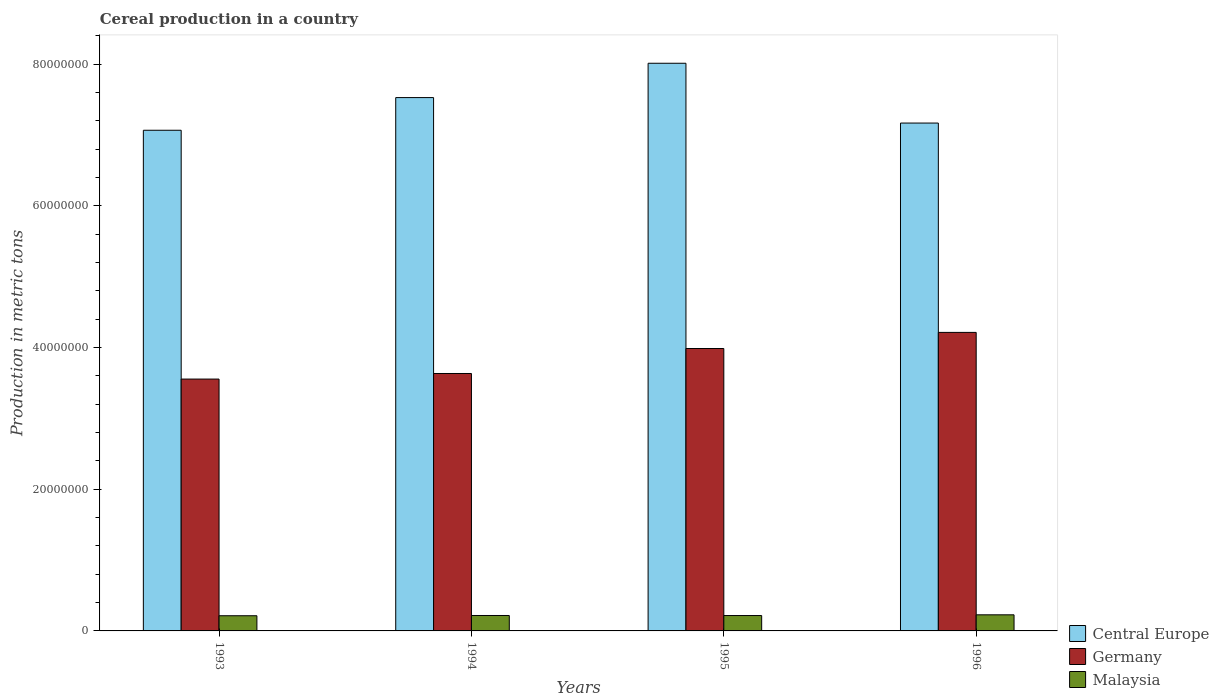How many groups of bars are there?
Offer a very short reply. 4. Are the number of bars on each tick of the X-axis equal?
Keep it short and to the point. Yes. How many bars are there on the 4th tick from the left?
Offer a very short reply. 3. How many bars are there on the 2nd tick from the right?
Your response must be concise. 3. In how many cases, is the number of bars for a given year not equal to the number of legend labels?
Provide a succinct answer. 0. What is the total cereal production in Central Europe in 1995?
Your answer should be very brief. 8.01e+07. Across all years, what is the maximum total cereal production in Germany?
Ensure brevity in your answer.  4.21e+07. Across all years, what is the minimum total cereal production in Central Europe?
Provide a short and direct response. 7.07e+07. In which year was the total cereal production in Germany minimum?
Your response must be concise. 1993. What is the total total cereal production in Central Europe in the graph?
Offer a very short reply. 2.98e+08. What is the difference between the total cereal production in Germany in 1995 and that in 1996?
Provide a short and direct response. -2.27e+06. What is the difference between the total cereal production in Central Europe in 1996 and the total cereal production in Malaysia in 1995?
Provide a succinct answer. 6.95e+07. What is the average total cereal production in Central Europe per year?
Provide a succinct answer. 7.44e+07. In the year 1993, what is the difference between the total cereal production in Malaysia and total cereal production in Central Europe?
Make the answer very short. -6.85e+07. What is the ratio of the total cereal production in Germany in 1994 to that in 1995?
Keep it short and to the point. 0.91. Is the total cereal production in Central Europe in 1993 less than that in 1996?
Offer a terse response. Yes. Is the difference between the total cereal production in Malaysia in 1993 and 1996 greater than the difference between the total cereal production in Central Europe in 1993 and 1996?
Make the answer very short. Yes. What is the difference between the highest and the second highest total cereal production in Central Europe?
Provide a short and direct response. 4.85e+06. What is the difference between the highest and the lowest total cereal production in Malaysia?
Ensure brevity in your answer.  1.31e+05. What does the 3rd bar from the right in 1993 represents?
Provide a short and direct response. Central Europe. How many bars are there?
Your answer should be very brief. 12. Are all the bars in the graph horizontal?
Make the answer very short. No. How many years are there in the graph?
Ensure brevity in your answer.  4. What is the difference between two consecutive major ticks on the Y-axis?
Provide a succinct answer. 2.00e+07. Are the values on the major ticks of Y-axis written in scientific E-notation?
Make the answer very short. No. Does the graph contain any zero values?
Make the answer very short. No. Does the graph contain grids?
Provide a short and direct response. No. How many legend labels are there?
Ensure brevity in your answer.  3. What is the title of the graph?
Make the answer very short. Cereal production in a country. What is the label or title of the X-axis?
Your answer should be very brief. Years. What is the label or title of the Y-axis?
Your response must be concise. Production in metric tons. What is the Production in metric tons of Central Europe in 1993?
Offer a very short reply. 7.07e+07. What is the Production in metric tons in Germany in 1993?
Make the answer very short. 3.55e+07. What is the Production in metric tons in Malaysia in 1993?
Offer a terse response. 2.14e+06. What is the Production in metric tons of Central Europe in 1994?
Your response must be concise. 7.53e+07. What is the Production in metric tons of Germany in 1994?
Your answer should be compact. 3.63e+07. What is the Production in metric tons in Malaysia in 1994?
Give a very brief answer. 2.18e+06. What is the Production in metric tons in Central Europe in 1995?
Offer a terse response. 8.01e+07. What is the Production in metric tons of Germany in 1995?
Make the answer very short. 3.99e+07. What is the Production in metric tons in Malaysia in 1995?
Give a very brief answer. 2.17e+06. What is the Production in metric tons of Central Europe in 1996?
Your response must be concise. 7.17e+07. What is the Production in metric tons of Germany in 1996?
Give a very brief answer. 4.21e+07. What is the Production in metric tons of Malaysia in 1996?
Ensure brevity in your answer.  2.27e+06. Across all years, what is the maximum Production in metric tons in Central Europe?
Provide a succinct answer. 8.01e+07. Across all years, what is the maximum Production in metric tons of Germany?
Provide a short and direct response. 4.21e+07. Across all years, what is the maximum Production in metric tons of Malaysia?
Your answer should be very brief. 2.27e+06. Across all years, what is the minimum Production in metric tons of Central Europe?
Provide a short and direct response. 7.07e+07. Across all years, what is the minimum Production in metric tons in Germany?
Give a very brief answer. 3.55e+07. Across all years, what is the minimum Production in metric tons in Malaysia?
Make the answer very short. 2.14e+06. What is the total Production in metric tons of Central Europe in the graph?
Provide a short and direct response. 2.98e+08. What is the total Production in metric tons of Germany in the graph?
Your answer should be compact. 1.54e+08. What is the total Production in metric tons of Malaysia in the graph?
Make the answer very short. 8.76e+06. What is the difference between the Production in metric tons in Central Europe in 1993 and that in 1994?
Make the answer very short. -4.61e+06. What is the difference between the Production in metric tons in Germany in 1993 and that in 1994?
Your answer should be very brief. -7.87e+05. What is the difference between the Production in metric tons of Malaysia in 1993 and that in 1994?
Make the answer very short. -3.63e+04. What is the difference between the Production in metric tons in Central Europe in 1993 and that in 1995?
Your response must be concise. -9.46e+06. What is the difference between the Production in metric tons of Germany in 1993 and that in 1995?
Make the answer very short. -4.31e+06. What is the difference between the Production in metric tons in Malaysia in 1993 and that in 1995?
Give a very brief answer. -2.78e+04. What is the difference between the Production in metric tons of Central Europe in 1993 and that in 1996?
Provide a succinct answer. -1.02e+06. What is the difference between the Production in metric tons of Germany in 1993 and that in 1996?
Provide a short and direct response. -6.59e+06. What is the difference between the Production in metric tons of Malaysia in 1993 and that in 1996?
Give a very brief answer. -1.31e+05. What is the difference between the Production in metric tons of Central Europe in 1994 and that in 1995?
Provide a succinct answer. -4.85e+06. What is the difference between the Production in metric tons of Germany in 1994 and that in 1995?
Offer a very short reply. -3.53e+06. What is the difference between the Production in metric tons in Malaysia in 1994 and that in 1995?
Your answer should be very brief. 8517. What is the difference between the Production in metric tons in Central Europe in 1994 and that in 1996?
Offer a very short reply. 3.59e+06. What is the difference between the Production in metric tons of Germany in 1994 and that in 1996?
Give a very brief answer. -5.80e+06. What is the difference between the Production in metric tons in Malaysia in 1994 and that in 1996?
Your answer should be very brief. -9.47e+04. What is the difference between the Production in metric tons of Central Europe in 1995 and that in 1996?
Give a very brief answer. 8.44e+06. What is the difference between the Production in metric tons in Germany in 1995 and that in 1996?
Keep it short and to the point. -2.27e+06. What is the difference between the Production in metric tons of Malaysia in 1995 and that in 1996?
Your answer should be compact. -1.03e+05. What is the difference between the Production in metric tons of Central Europe in 1993 and the Production in metric tons of Germany in 1994?
Keep it short and to the point. 3.43e+07. What is the difference between the Production in metric tons in Central Europe in 1993 and the Production in metric tons in Malaysia in 1994?
Keep it short and to the point. 6.85e+07. What is the difference between the Production in metric tons in Germany in 1993 and the Production in metric tons in Malaysia in 1994?
Make the answer very short. 3.34e+07. What is the difference between the Production in metric tons in Central Europe in 1993 and the Production in metric tons in Germany in 1995?
Your answer should be compact. 3.08e+07. What is the difference between the Production in metric tons of Central Europe in 1993 and the Production in metric tons of Malaysia in 1995?
Your answer should be compact. 6.85e+07. What is the difference between the Production in metric tons of Germany in 1993 and the Production in metric tons of Malaysia in 1995?
Provide a short and direct response. 3.34e+07. What is the difference between the Production in metric tons of Central Europe in 1993 and the Production in metric tons of Germany in 1996?
Give a very brief answer. 2.85e+07. What is the difference between the Production in metric tons in Central Europe in 1993 and the Production in metric tons in Malaysia in 1996?
Provide a succinct answer. 6.84e+07. What is the difference between the Production in metric tons in Germany in 1993 and the Production in metric tons in Malaysia in 1996?
Provide a short and direct response. 3.33e+07. What is the difference between the Production in metric tons in Central Europe in 1994 and the Production in metric tons in Germany in 1995?
Make the answer very short. 3.54e+07. What is the difference between the Production in metric tons of Central Europe in 1994 and the Production in metric tons of Malaysia in 1995?
Provide a short and direct response. 7.31e+07. What is the difference between the Production in metric tons in Germany in 1994 and the Production in metric tons in Malaysia in 1995?
Ensure brevity in your answer.  3.42e+07. What is the difference between the Production in metric tons in Central Europe in 1994 and the Production in metric tons in Germany in 1996?
Offer a terse response. 3.31e+07. What is the difference between the Production in metric tons of Central Europe in 1994 and the Production in metric tons of Malaysia in 1996?
Keep it short and to the point. 7.30e+07. What is the difference between the Production in metric tons of Germany in 1994 and the Production in metric tons of Malaysia in 1996?
Your response must be concise. 3.41e+07. What is the difference between the Production in metric tons of Central Europe in 1995 and the Production in metric tons of Germany in 1996?
Make the answer very short. 3.80e+07. What is the difference between the Production in metric tons of Central Europe in 1995 and the Production in metric tons of Malaysia in 1996?
Ensure brevity in your answer.  7.79e+07. What is the difference between the Production in metric tons of Germany in 1995 and the Production in metric tons of Malaysia in 1996?
Offer a terse response. 3.76e+07. What is the average Production in metric tons in Central Europe per year?
Your answer should be compact. 7.44e+07. What is the average Production in metric tons of Germany per year?
Keep it short and to the point. 3.85e+07. What is the average Production in metric tons in Malaysia per year?
Provide a succinct answer. 2.19e+06. In the year 1993, what is the difference between the Production in metric tons in Central Europe and Production in metric tons in Germany?
Keep it short and to the point. 3.51e+07. In the year 1993, what is the difference between the Production in metric tons in Central Europe and Production in metric tons in Malaysia?
Ensure brevity in your answer.  6.85e+07. In the year 1993, what is the difference between the Production in metric tons in Germany and Production in metric tons in Malaysia?
Give a very brief answer. 3.34e+07. In the year 1994, what is the difference between the Production in metric tons of Central Europe and Production in metric tons of Germany?
Give a very brief answer. 3.89e+07. In the year 1994, what is the difference between the Production in metric tons of Central Europe and Production in metric tons of Malaysia?
Give a very brief answer. 7.31e+07. In the year 1994, what is the difference between the Production in metric tons in Germany and Production in metric tons in Malaysia?
Keep it short and to the point. 3.42e+07. In the year 1995, what is the difference between the Production in metric tons of Central Europe and Production in metric tons of Germany?
Provide a succinct answer. 4.03e+07. In the year 1995, what is the difference between the Production in metric tons in Central Europe and Production in metric tons in Malaysia?
Your response must be concise. 7.80e+07. In the year 1995, what is the difference between the Production in metric tons of Germany and Production in metric tons of Malaysia?
Offer a very short reply. 3.77e+07. In the year 1996, what is the difference between the Production in metric tons in Central Europe and Production in metric tons in Germany?
Give a very brief answer. 2.95e+07. In the year 1996, what is the difference between the Production in metric tons in Central Europe and Production in metric tons in Malaysia?
Provide a succinct answer. 6.94e+07. In the year 1996, what is the difference between the Production in metric tons of Germany and Production in metric tons of Malaysia?
Your response must be concise. 3.99e+07. What is the ratio of the Production in metric tons in Central Europe in 1993 to that in 1994?
Ensure brevity in your answer.  0.94. What is the ratio of the Production in metric tons in Germany in 1993 to that in 1994?
Give a very brief answer. 0.98. What is the ratio of the Production in metric tons in Malaysia in 1993 to that in 1994?
Keep it short and to the point. 0.98. What is the ratio of the Production in metric tons in Central Europe in 1993 to that in 1995?
Offer a very short reply. 0.88. What is the ratio of the Production in metric tons of Germany in 1993 to that in 1995?
Offer a very short reply. 0.89. What is the ratio of the Production in metric tons of Malaysia in 1993 to that in 1995?
Provide a short and direct response. 0.99. What is the ratio of the Production in metric tons of Central Europe in 1993 to that in 1996?
Make the answer very short. 0.99. What is the ratio of the Production in metric tons in Germany in 1993 to that in 1996?
Keep it short and to the point. 0.84. What is the ratio of the Production in metric tons of Malaysia in 1993 to that in 1996?
Your answer should be very brief. 0.94. What is the ratio of the Production in metric tons in Central Europe in 1994 to that in 1995?
Provide a succinct answer. 0.94. What is the ratio of the Production in metric tons of Germany in 1994 to that in 1995?
Offer a very short reply. 0.91. What is the ratio of the Production in metric tons of Malaysia in 1994 to that in 1995?
Your answer should be very brief. 1. What is the ratio of the Production in metric tons in Central Europe in 1994 to that in 1996?
Ensure brevity in your answer.  1.05. What is the ratio of the Production in metric tons of Germany in 1994 to that in 1996?
Your answer should be very brief. 0.86. What is the ratio of the Production in metric tons of Central Europe in 1995 to that in 1996?
Keep it short and to the point. 1.12. What is the ratio of the Production in metric tons in Germany in 1995 to that in 1996?
Provide a succinct answer. 0.95. What is the ratio of the Production in metric tons of Malaysia in 1995 to that in 1996?
Keep it short and to the point. 0.95. What is the difference between the highest and the second highest Production in metric tons of Central Europe?
Make the answer very short. 4.85e+06. What is the difference between the highest and the second highest Production in metric tons in Germany?
Ensure brevity in your answer.  2.27e+06. What is the difference between the highest and the second highest Production in metric tons in Malaysia?
Make the answer very short. 9.47e+04. What is the difference between the highest and the lowest Production in metric tons of Central Europe?
Offer a terse response. 9.46e+06. What is the difference between the highest and the lowest Production in metric tons in Germany?
Offer a very short reply. 6.59e+06. What is the difference between the highest and the lowest Production in metric tons in Malaysia?
Provide a short and direct response. 1.31e+05. 